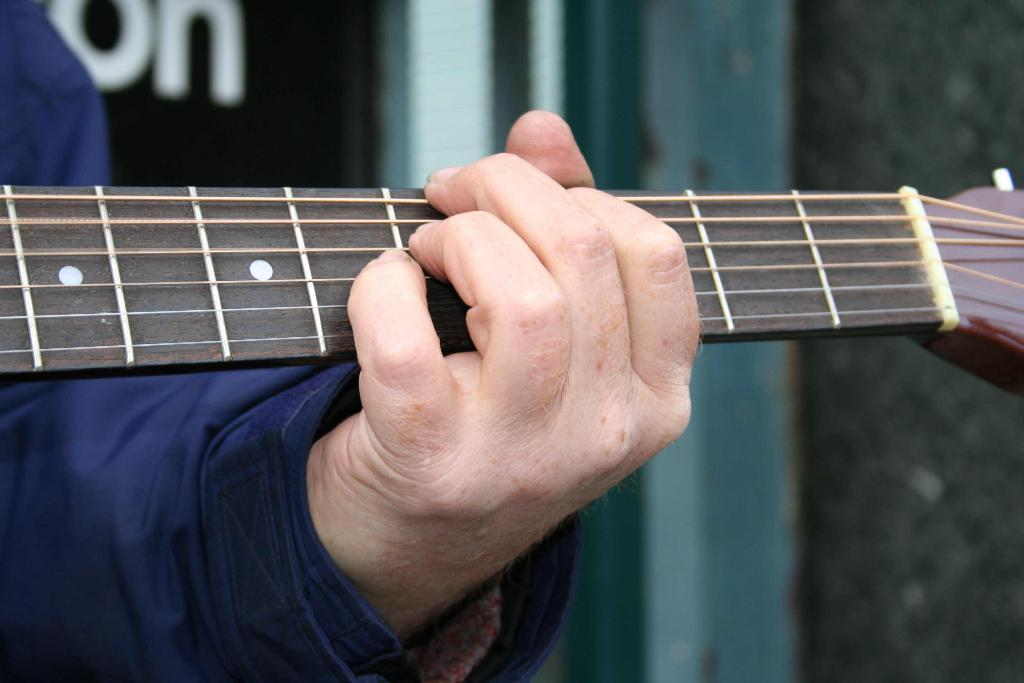What is the person holding in the image? There is a person's hand holding a guitar in the image. What color is the shirt the person is wearing? The person is wearing a blue color shirt. What can be seen in the background of the image? There is a wall in the background of the image. What type of vegetable is being used as a pick to play the guitar in the image? There is no vegetable being used as a pick to play the guitar in the image; the person is using their hand. 